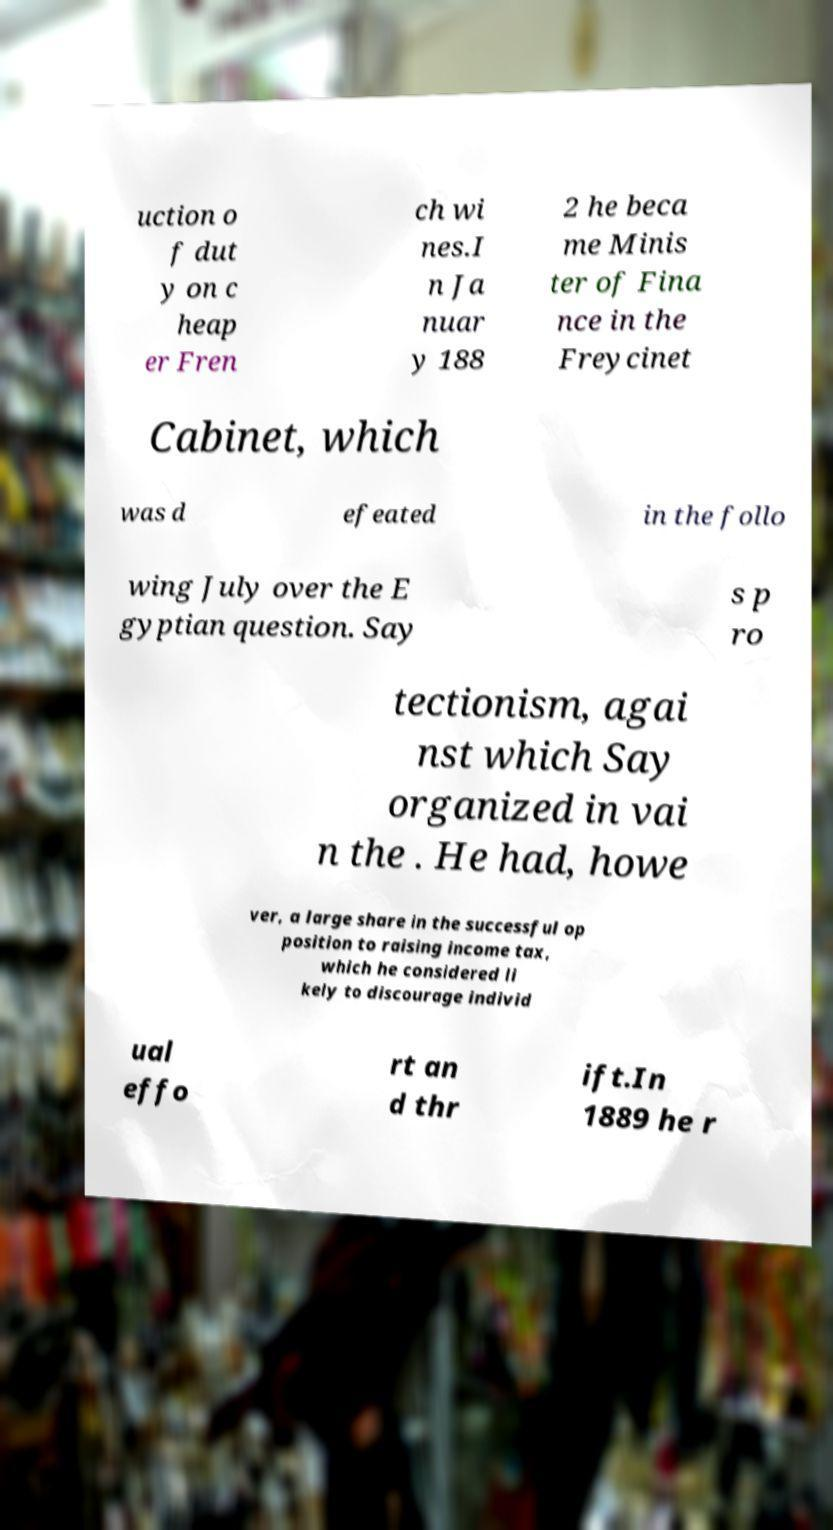Could you assist in decoding the text presented in this image and type it out clearly? uction o f dut y on c heap er Fren ch wi nes.I n Ja nuar y 188 2 he beca me Minis ter of Fina nce in the Freycinet Cabinet, which was d efeated in the follo wing July over the E gyptian question. Say s p ro tectionism, agai nst which Say organized in vai n the . He had, howe ver, a large share in the successful op position to raising income tax, which he considered li kely to discourage individ ual effo rt an d thr ift.In 1889 he r 